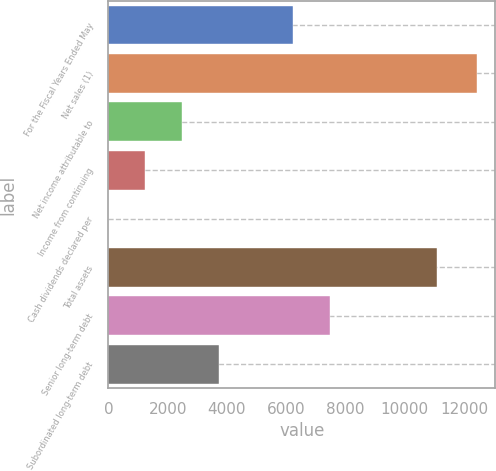<chart> <loc_0><loc_0><loc_500><loc_500><bar_chart><fcel>For the Fiscal Years Ended May<fcel>Net sales (1)<fcel>Net income attributable to<fcel>Income from continuing<fcel>Cash dividends declared per<fcel>Total assets<fcel>Senior long-term debt<fcel>Subordinated long-term debt<nl><fcel>6219.91<fcel>12439.1<fcel>2488.42<fcel>1244.59<fcel>0.76<fcel>11073.3<fcel>7463.74<fcel>3732.25<nl></chart> 